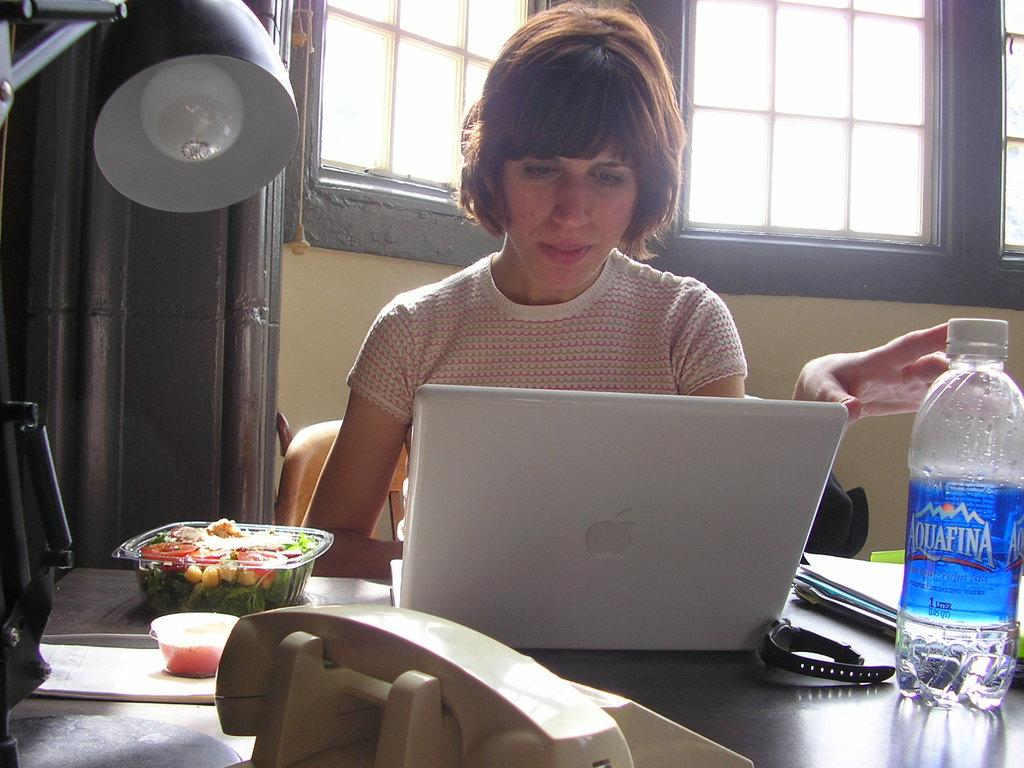What is the woman in the image doing? The woman is sitting on a chair and working on a laptop in the image. Can you describe the surroundings of the woman? There is a window visible in the image, and there is a water bottle on the right side and a lamp on the left side. What might the woman be using for hydration? The woman might be using the water bottle for hydration. What could be providing light for the woman? The lamp on the left side of the image could be providing light for the woman. What type of leather material is covering the clock in the image? There is no clock present in the image, so it is not possible to determine the type of leather material covering it. 